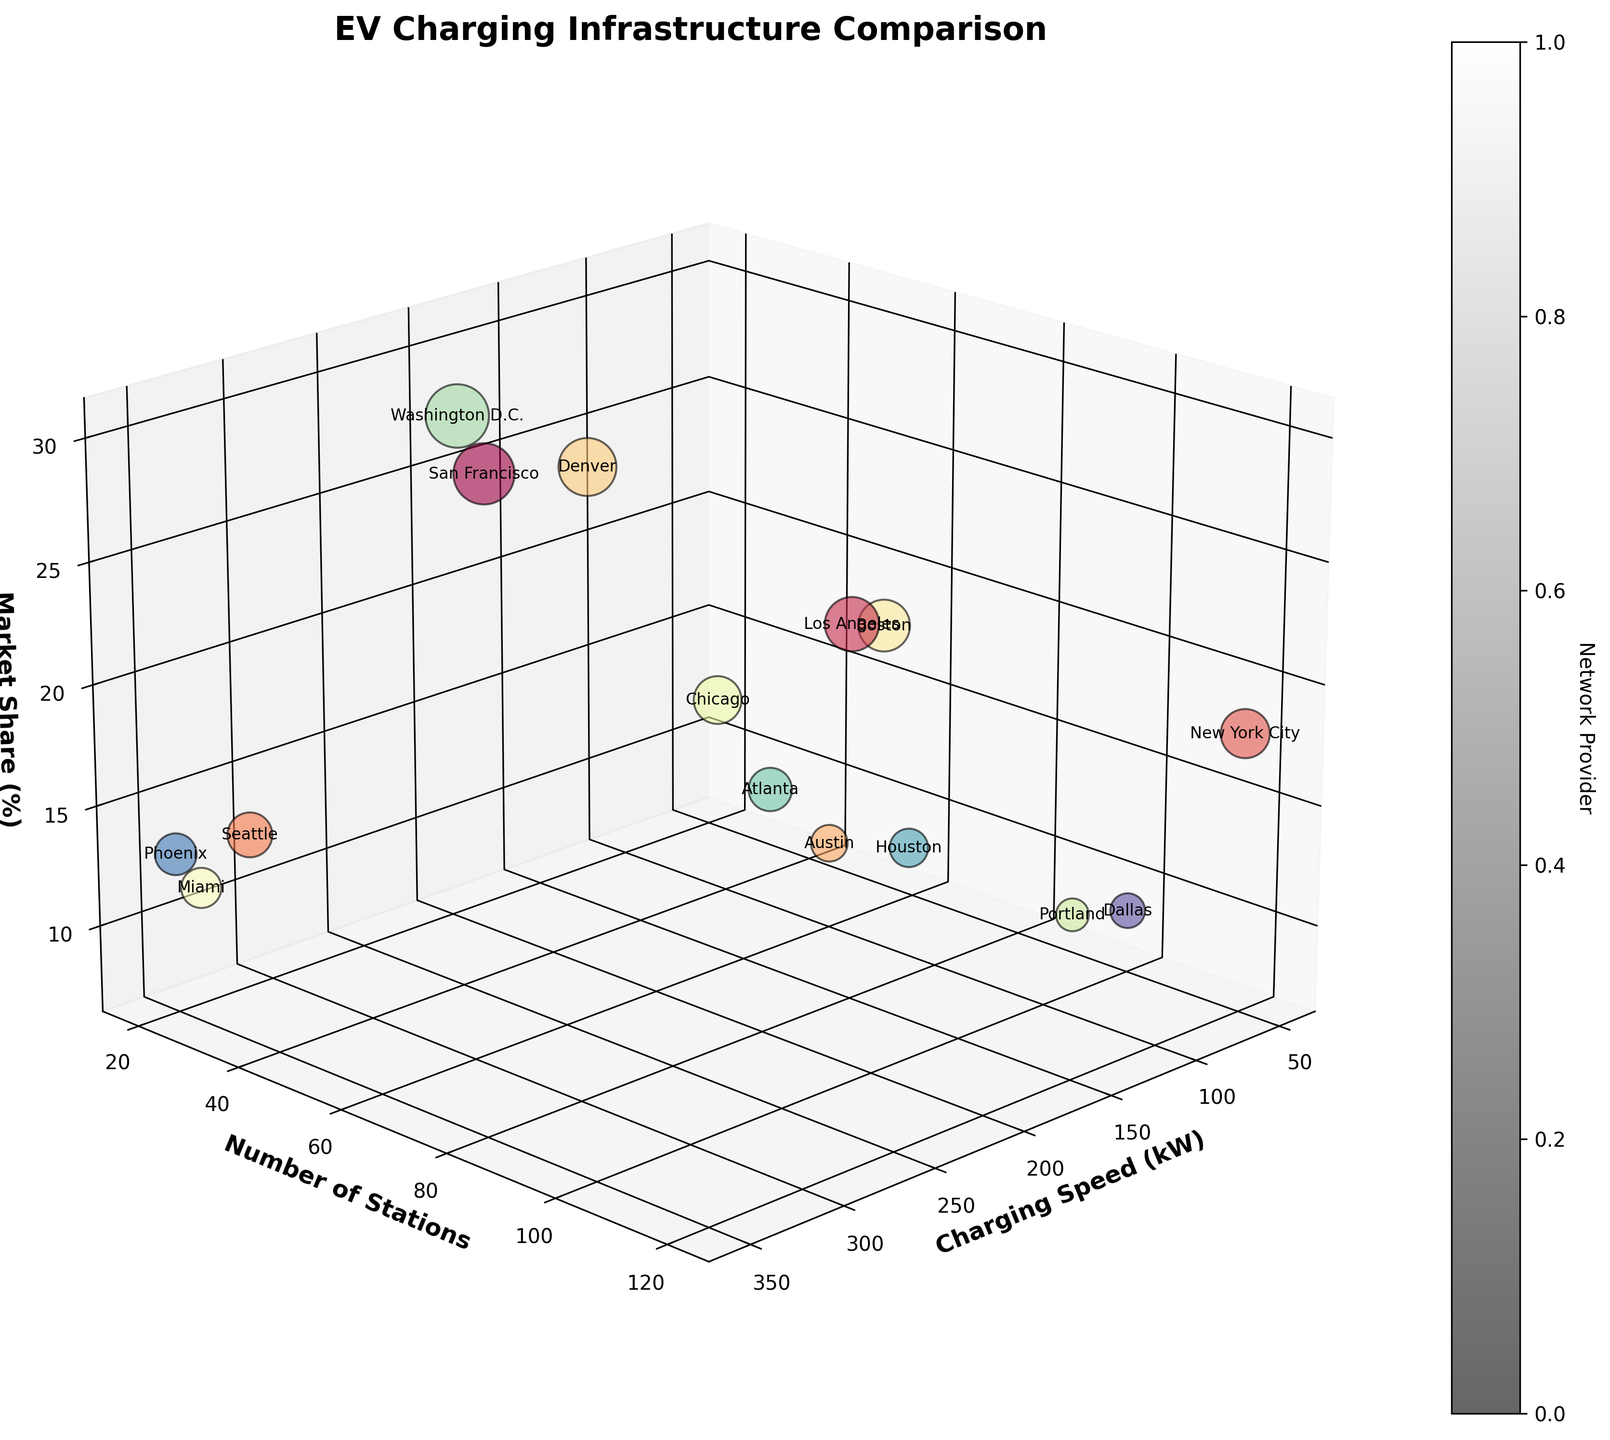What's the title of the figure? The title is typically found at the top of the figure. In this case, it reads "EV Charging Infrastructure Comparison".
Answer: EV Charging Infrastructure Comparison Which axis represents the Charging Speed (kW)? The axis labels are crucial for understanding the represented dimensions. Here, the x-axis label is "Charging Speed (kW)".
Answer: x-axis How many charging stations are there in Los Angeles? Look for the text label "Los Angeles" and find where it aligns on the y-axis, which represents the number of stations. Los Angeles aligns with 80 stations.
Answer: 80 Which city has the highest market share (%)? Identify the highest point on the z-axis and trace the label associated with that data point. Washington D.C. has the highest market share (%) at 30%.
Answer: Washington D.C What are the axis labels in the figure? Check the axes labels for each axis in the figure, which are "Charging Speed (kW)", "Number of Stations", and "Market Share (%)".
Answer: Charging Speed (kW), Number of Stations, Market Share (%) Which city has the most charging stations provided by ChargePoint? Identify the cities with ChargePoint as the network provider and find which has the highest value on the y-axis. New York City has 120 stations.
Answer: New York City How does the number of stations in Austin compare to that in Boston? Check the y-axis values for both Austin and Boston. Austin has 60 stations, while Boston has 70. Boston has 10 more stations.
Answer: Boston has 10 more stations Which city has the fastest charging speed? Identify the highest value on the x-axis and trace it to the corresponding city label. Seattle and Phoenix both have a charging speed of 350 kW.
Answer: Seattle and Phoenix What is the combined market share (%) of cities provided by Tesla Supercharger? Identify all cities provided by Tesla Supercharger and sum their market share values: San Francisco (28%), Denver (25%), Washington D.C. (30%). The combined market share is 83%.
Answer: 83% What is the average number of stations for cities with a charging speed of 150 kW? Identify cities with 150 kW and sum up their number of stations: Los Angeles (80), Denver (30), Chicago (55), Atlanta (65). Then, calculate the average: (80+30+55+65)/4 = 57.5.
Answer: 57.5 